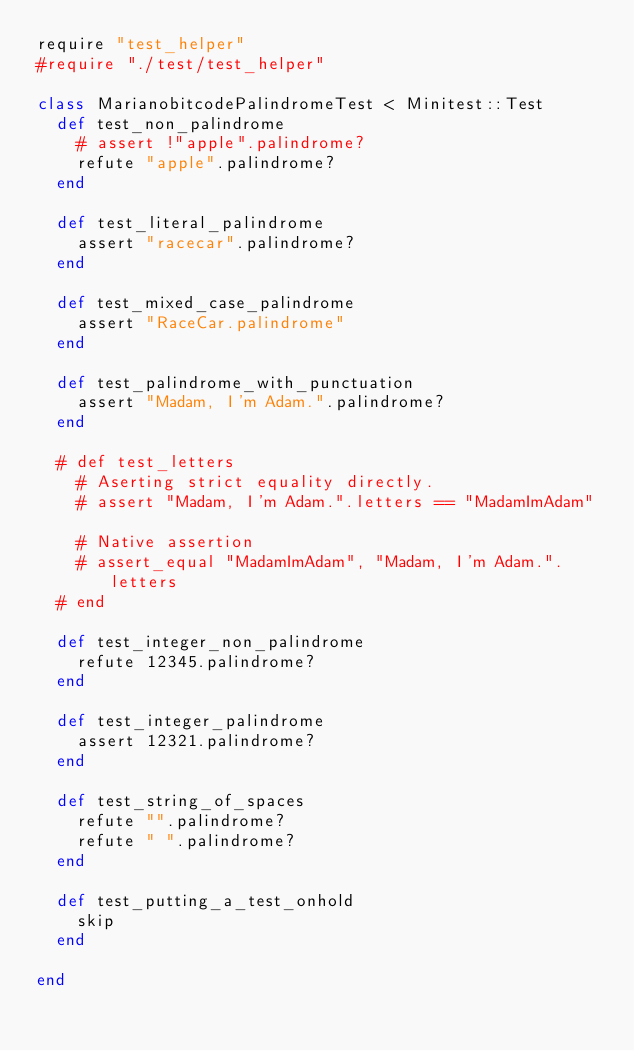<code> <loc_0><loc_0><loc_500><loc_500><_Ruby_>require "test_helper"
#require "./test/test_helper"

class MarianobitcodePalindromeTest < Minitest::Test
  def test_non_palindrome
    # assert !"apple".palindrome?
    refute "apple".palindrome?
  end

  def test_literal_palindrome
    assert "racecar".palindrome?
  end

  def test_mixed_case_palindrome
    assert "RaceCar.palindrome"
  end

  def test_palindrome_with_punctuation
    assert "Madam, I'm Adam.".palindrome?
  end

  # def test_letters
    # Aserting strict equality directly.
    # assert "Madam, I'm Adam.".letters == "MadamImAdam"

    # Native assertion
    # assert_equal "MadamImAdam", "Madam, I'm Adam.".letters
  # end

  def test_integer_non_palindrome
    refute 12345.palindrome?
  end

  def test_integer_palindrome
    assert 12321.palindrome?
  end

  def test_string_of_spaces
    refute "".palindrome?
    refute " ".palindrome?
  end

  def test_putting_a_test_onhold
    skip
  end

end
</code> 